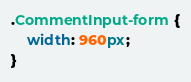<code> <loc_0><loc_0><loc_500><loc_500><_CSS_>.CommentInput-form {
    width: 960px;
}</code> 